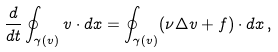<formula> <loc_0><loc_0><loc_500><loc_500>\frac { d } { d t } \oint _ { \gamma ( v ) } v \cdot d x = \oint _ { \gamma ( v ) } ( \nu \Delta v + f ) \cdot d x \, ,</formula> 